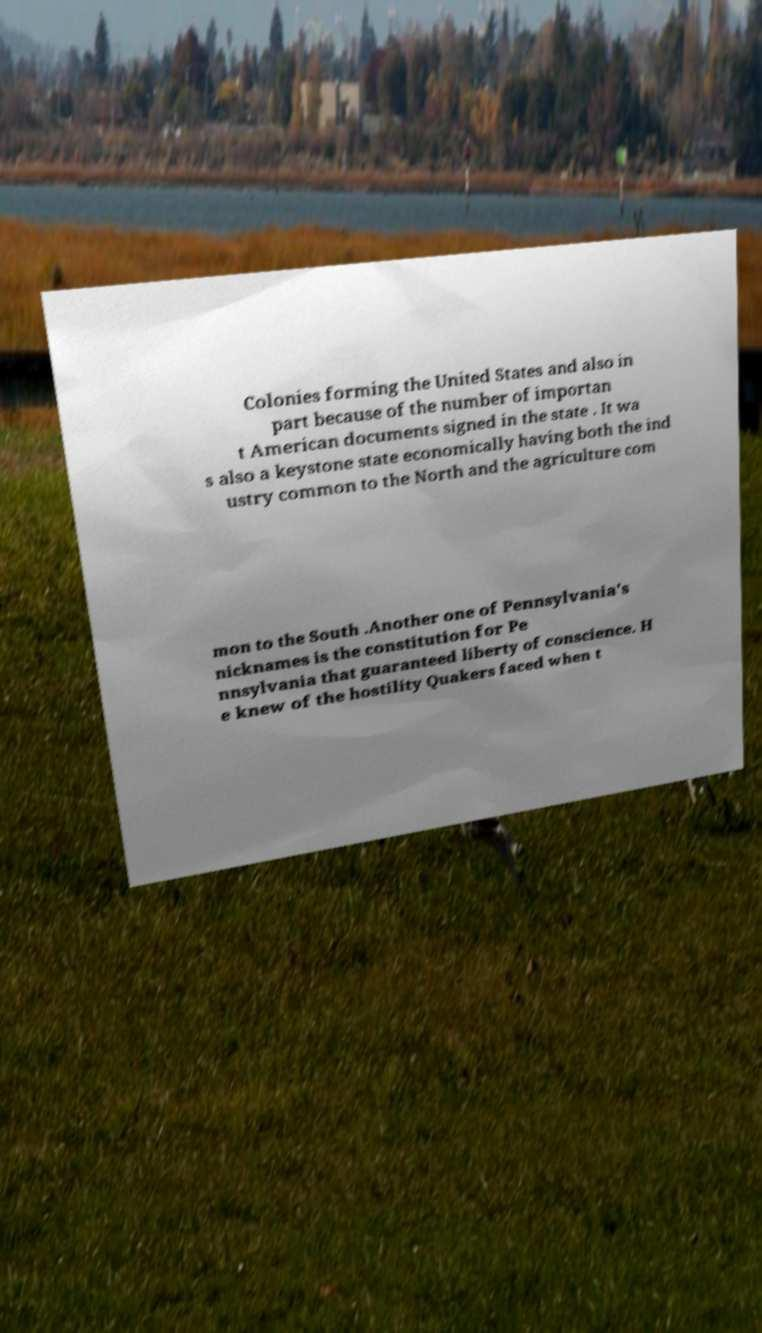Could you extract and type out the text from this image? Colonies forming the United States and also in part because of the number of importan t American documents signed in the state . It wa s also a keystone state economically having both the ind ustry common to the North and the agriculture com mon to the South .Another one of Pennsylvania's nicknames is the constitution for Pe nnsylvania that guaranteed liberty of conscience. H e knew of the hostility Quakers faced when t 